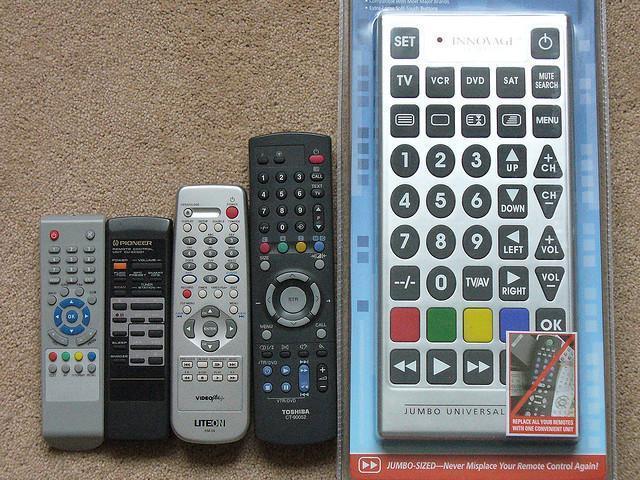How many remotes are there?
Give a very brief answer. 5. How many people are wearing a yellow shirt in the image?
Give a very brief answer. 0. 